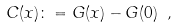<formula> <loc_0><loc_0><loc_500><loc_500>C ( x ) \colon = G ( x ) - G ( 0 ) \ ,</formula> 